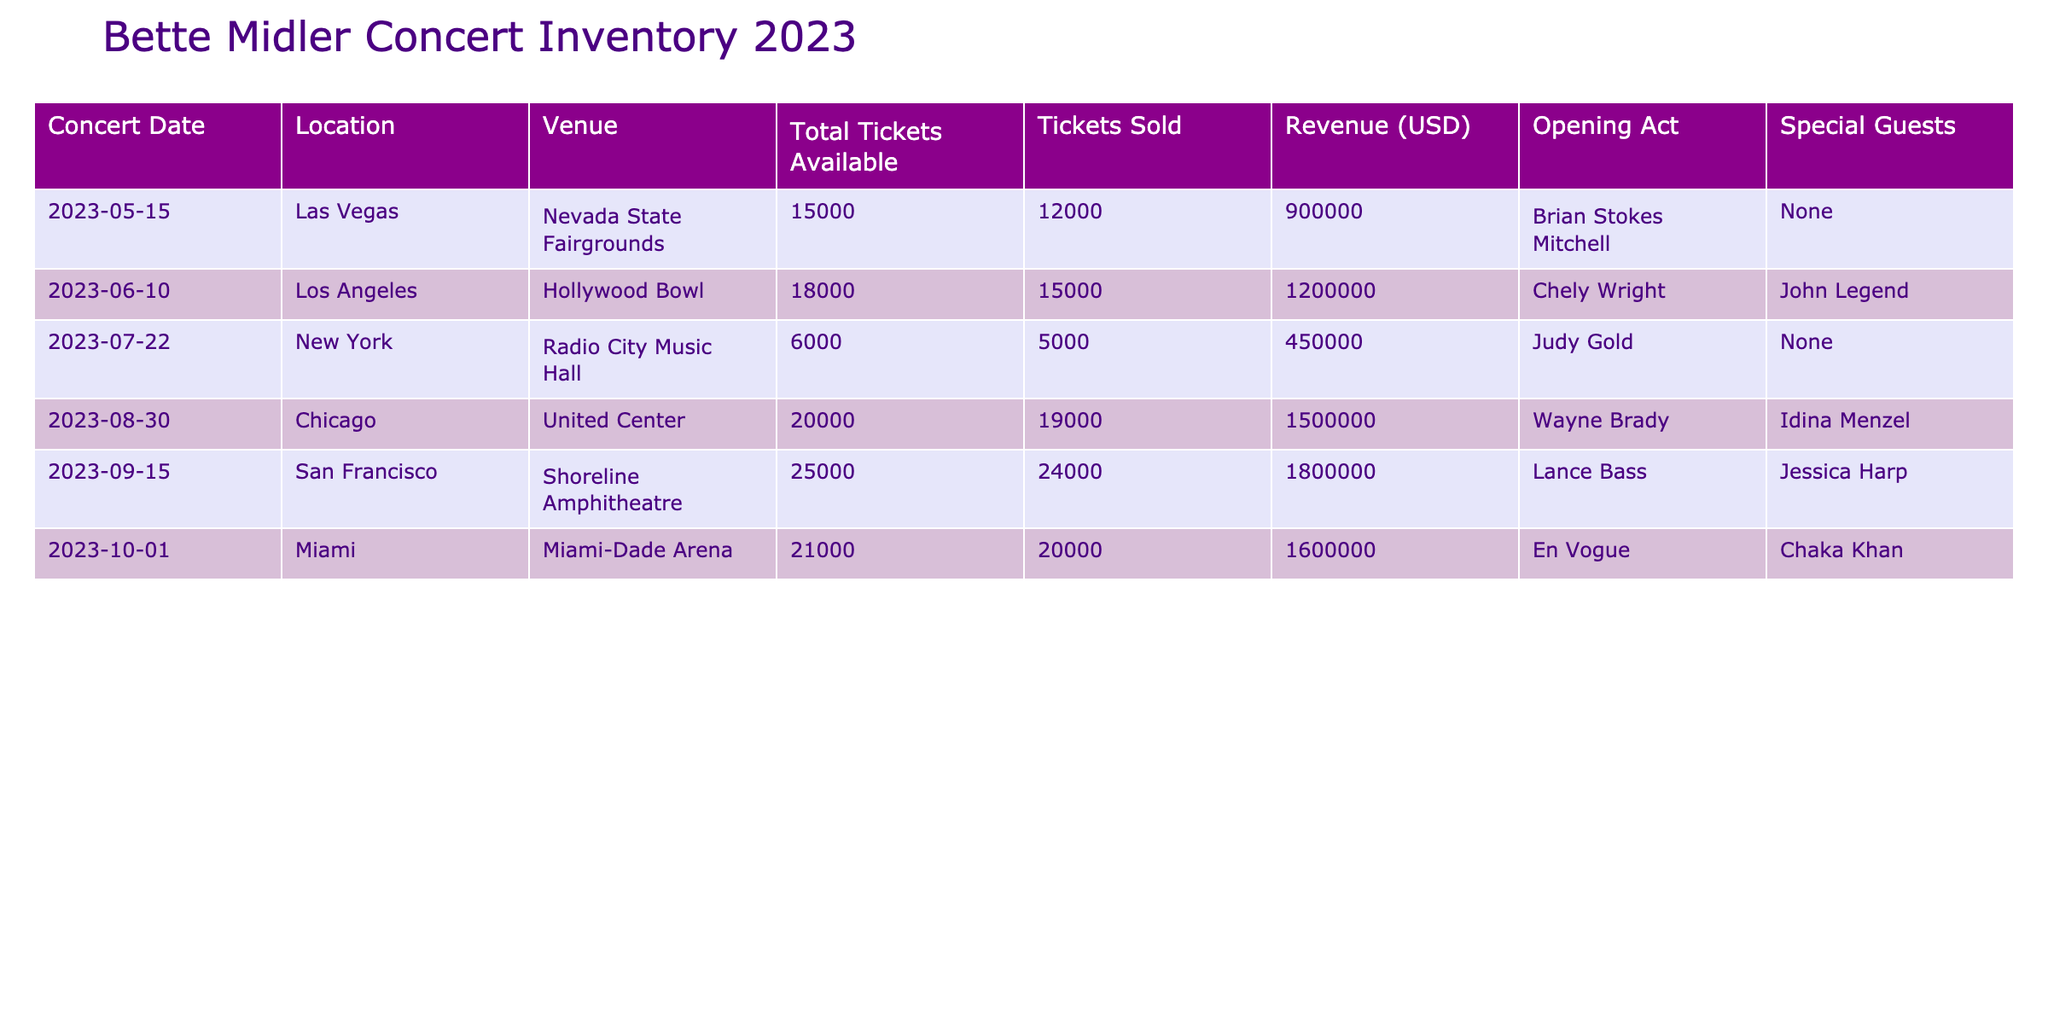What was the total revenue generated from the concert in Chicago? The revenue for the concert held in Chicago is listed in the table as 1,500,000 USD.
Answer: 1,500,000 USD Which concert had the highest ticket sales? By comparing the Tickets Sold column, the concert in San Francisco sold 24,000 tickets, which is the highest among all concerts listed.
Answer: San Francisco How many tickets were sold across all concerts in 2023? Summing the Tickets Sold from all concerts: 12,000 + 15,000 + 5,000 + 19,000 + 24,000 + 20,000 = 95,000 tickets sold in total.
Answer: 95,000 Did the concert in New York feature a special guest? The concert in New York did not have any special guests; it is indicated as "None" in the Special Guests column.
Answer: No What was the average revenue generated per concert in 2023? To find the average revenue, first sum the revenues: 900,000 + 1,200,000 + 450,000 + 1,500,000 + 1,800,000 + 1,600,000 = 7,450,000. Then, divide by the number of concerts (6): 7,450,000 / 6 ≈ 1,241,667.
Answer: Approximately 1,241,667 USD What percentage of tickets were sold for the concert in Miami? For the Miami concert, 20,000 tickets were sold out of 21,000 available. The percentage is calculated as (20,000 / 21,000) * 100 ≈ 95.24%.
Answer: Approximately 95.24% Which location had the fewest total tickets available? Reviewing the Total Tickets Available column, New York had 6,000 tickets available, which is the fewest compared to other locations.
Answer: New York Was Brian Stokes Mitchell the opening act for the concert in Los Angeles? According to the table, Chely Wright was the opening act for the concert in Los Angeles, not Brian Stokes Mitchell.
Answer: No 